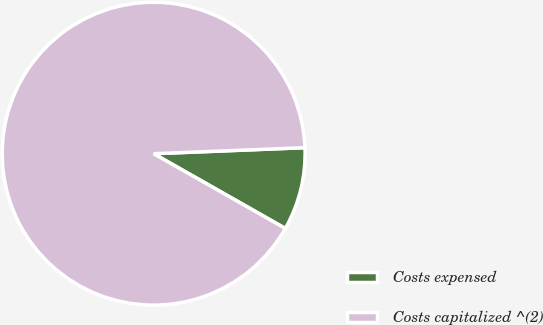Convert chart. <chart><loc_0><loc_0><loc_500><loc_500><pie_chart><fcel>Costs expensed<fcel>Costs capitalized ^(2)<nl><fcel>8.85%<fcel>91.15%<nl></chart> 